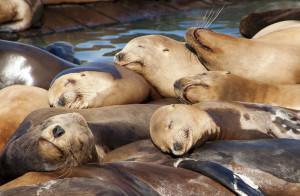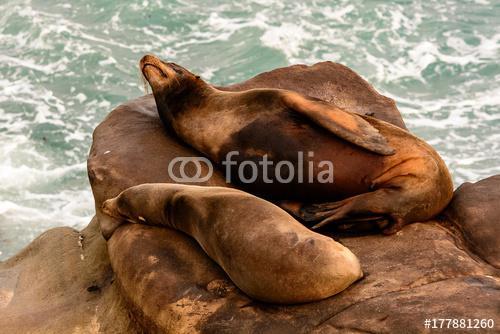The first image is the image on the left, the second image is the image on the right. Evaluate the accuracy of this statement regarding the images: "A black seal is sitting to the right of a brown seal.". Is it true? Answer yes or no. No. 